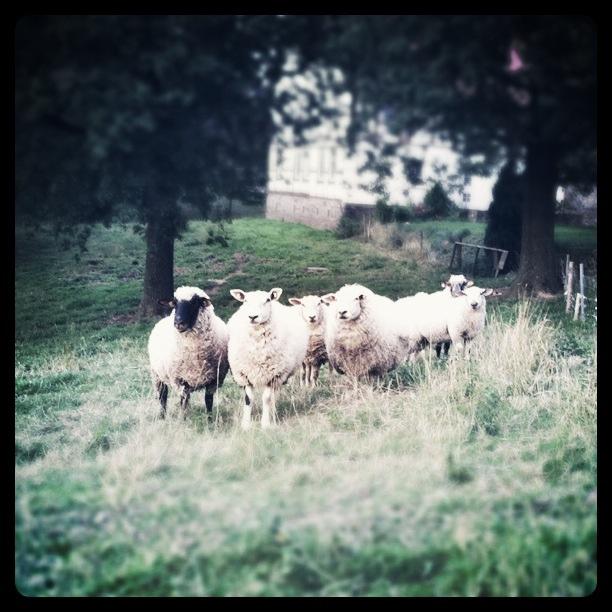Are there trees visible?
Answer briefly. Yes. How many sheep have black faces?
Concise answer only. 1. Is this an old image?
Short answer required. No. 